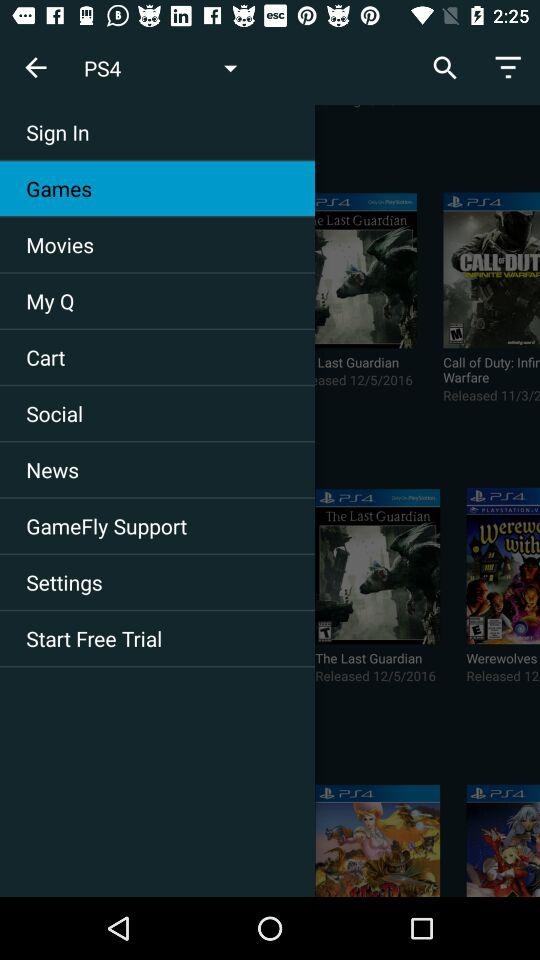What is the release date of "Playstation: The Last Guardian"? The release date of "Playstation: The Last Guardian" is December 5, 2016. 